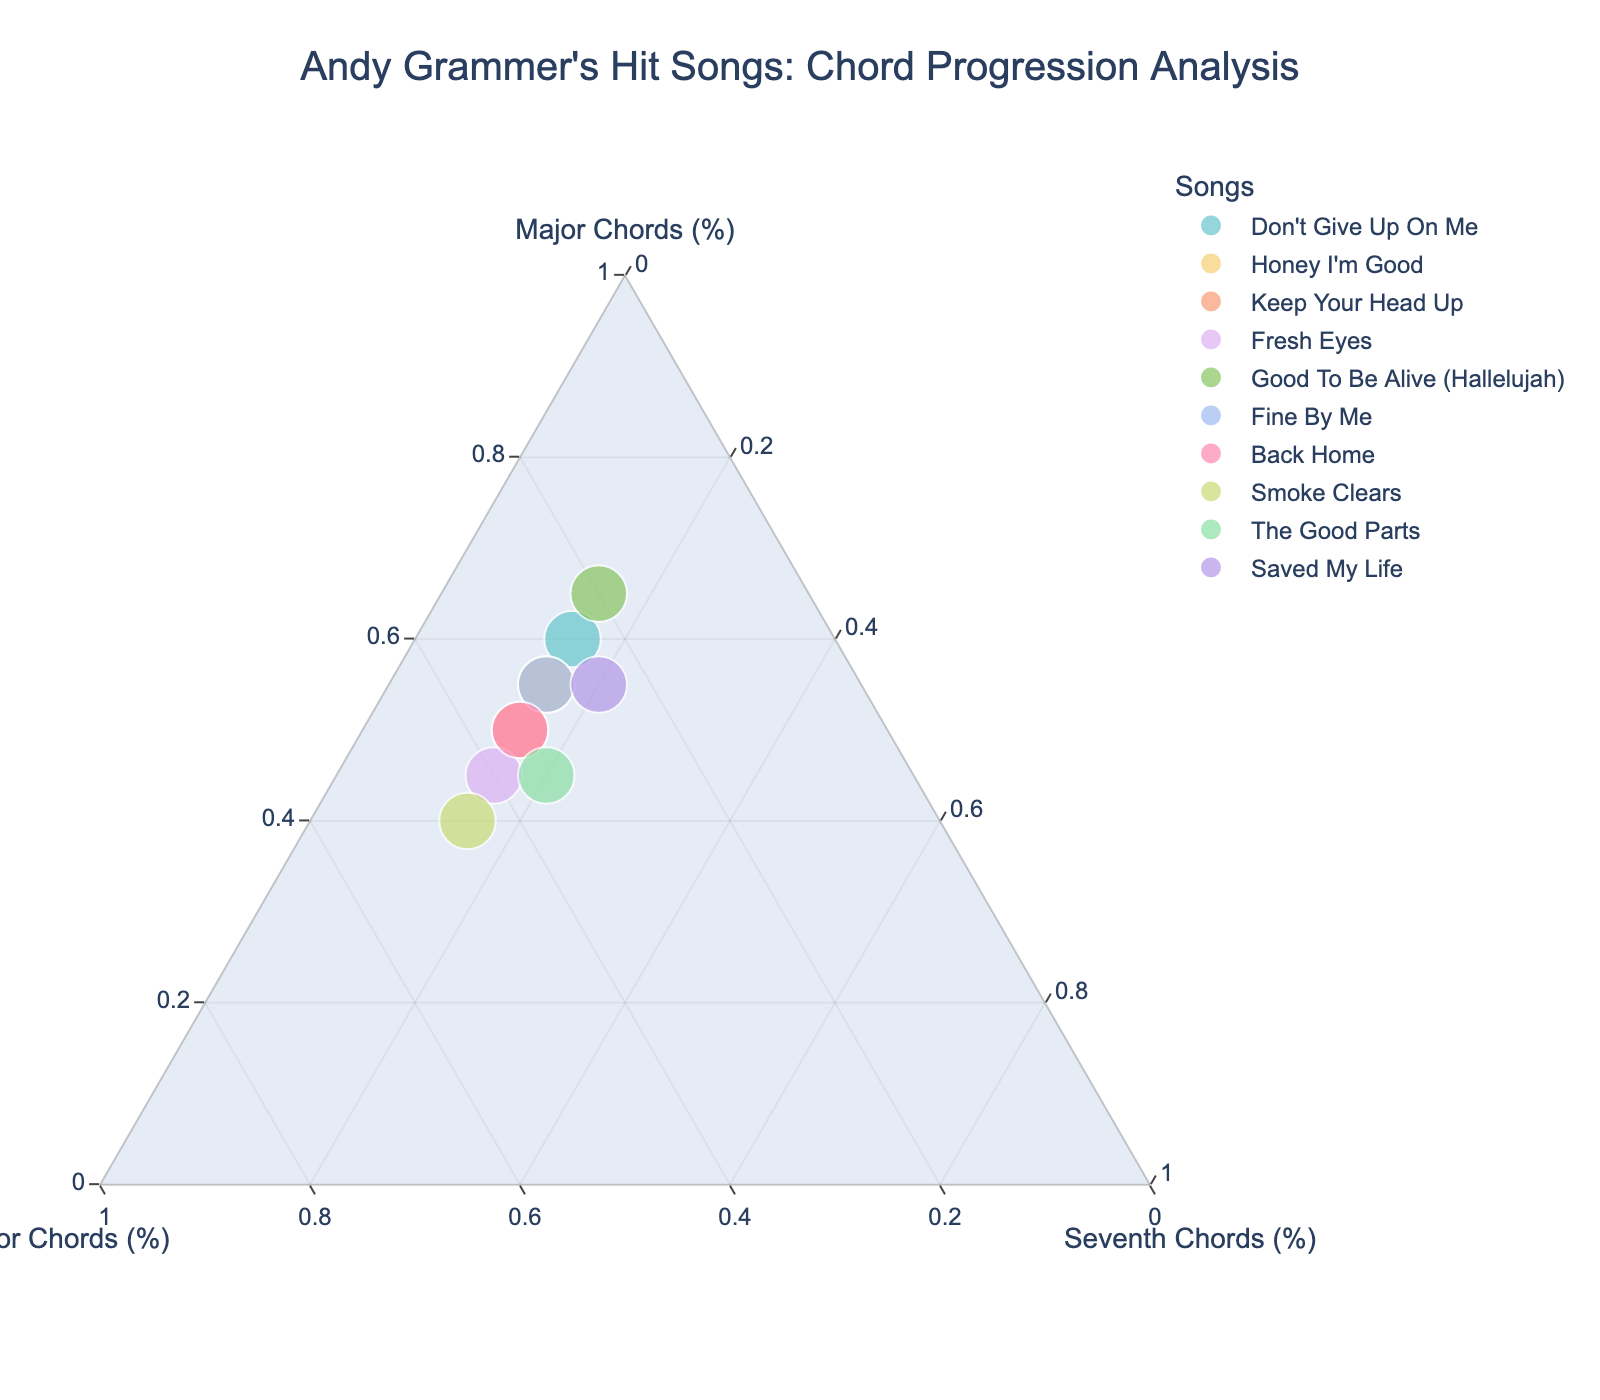What's the title of the plot? The title is displayed prominently at the top of the plot. It indicates the overall topic of the visualization.
Answer: Andy Grammer's Hit Songs: Chord Progression Analysis How many data points are there in the plot? Each data point represents one of Andy Grammer's hit songs. You can count the colored markers in the plot to determine the total number.
Answer: 10 Which song has the highest percentage of major chords? By examining the points closest to the apex labeled "Major Chords (%)," you can identify the song with the highest value.
Answer: Good To Be Alive (Hallelujah) Which two songs have the same percentage breakdown of chords? By visually inspecting the position of points, you can identify that some points may overlap completely, hinting at identical percentage distributions.
Answer: Honey I'm Good and Fine By Me What is the range of percentages for minor chords across all songs? Identify the minimum and maximum positions along the axis labeled "Minor Chords (%)." The range is the difference between the highest and lowest values.
Answer: 20% - 45% Which song is closest to the center of the plot? The song closest to the center will have the most balanced mix of major, minor, and seventh chords. Look for the point nearest to the center of the triangle.
Answer: The Good Parts Between "Don't Give Up On Me" and "Smoke Clears," which song uses a higher percentage of minor chords? Locate both points on the plot and compare their positions relative to the "Minor Chords (%)" axis.
Answer: Smoke Clears What can you say about the usage of seventh chords across all songs? Since all songs share a common percentage of seventh chords, it is noticeable that every point has the same distance from the "Seventh Chords (%)" axis.
Answer: 15% or 20% Which song has the most balanced chord progression? A balanced progression means the song is close to the center of the ternary plot, implying similar percentages of all three types of chords.
Answer: The Good Parts How does “Fresh Eyes” compare to “Keep Your Head Up” in terms of major and minor chords? Compare both points' positions along the "Major Chords (%)" and "Minor Chords (%)" axes. Fresh Eyes will have a lower percentage of major chords and a higher percentage of minor chords compared to Keep Your Head Up.
Answer: Fresh Eyes has fewer major chords and more minor chords compared to Keep Your Head Up 